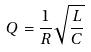<formula> <loc_0><loc_0><loc_500><loc_500>Q = \frac { 1 } { R } \sqrt { \frac { L } { C } }</formula> 